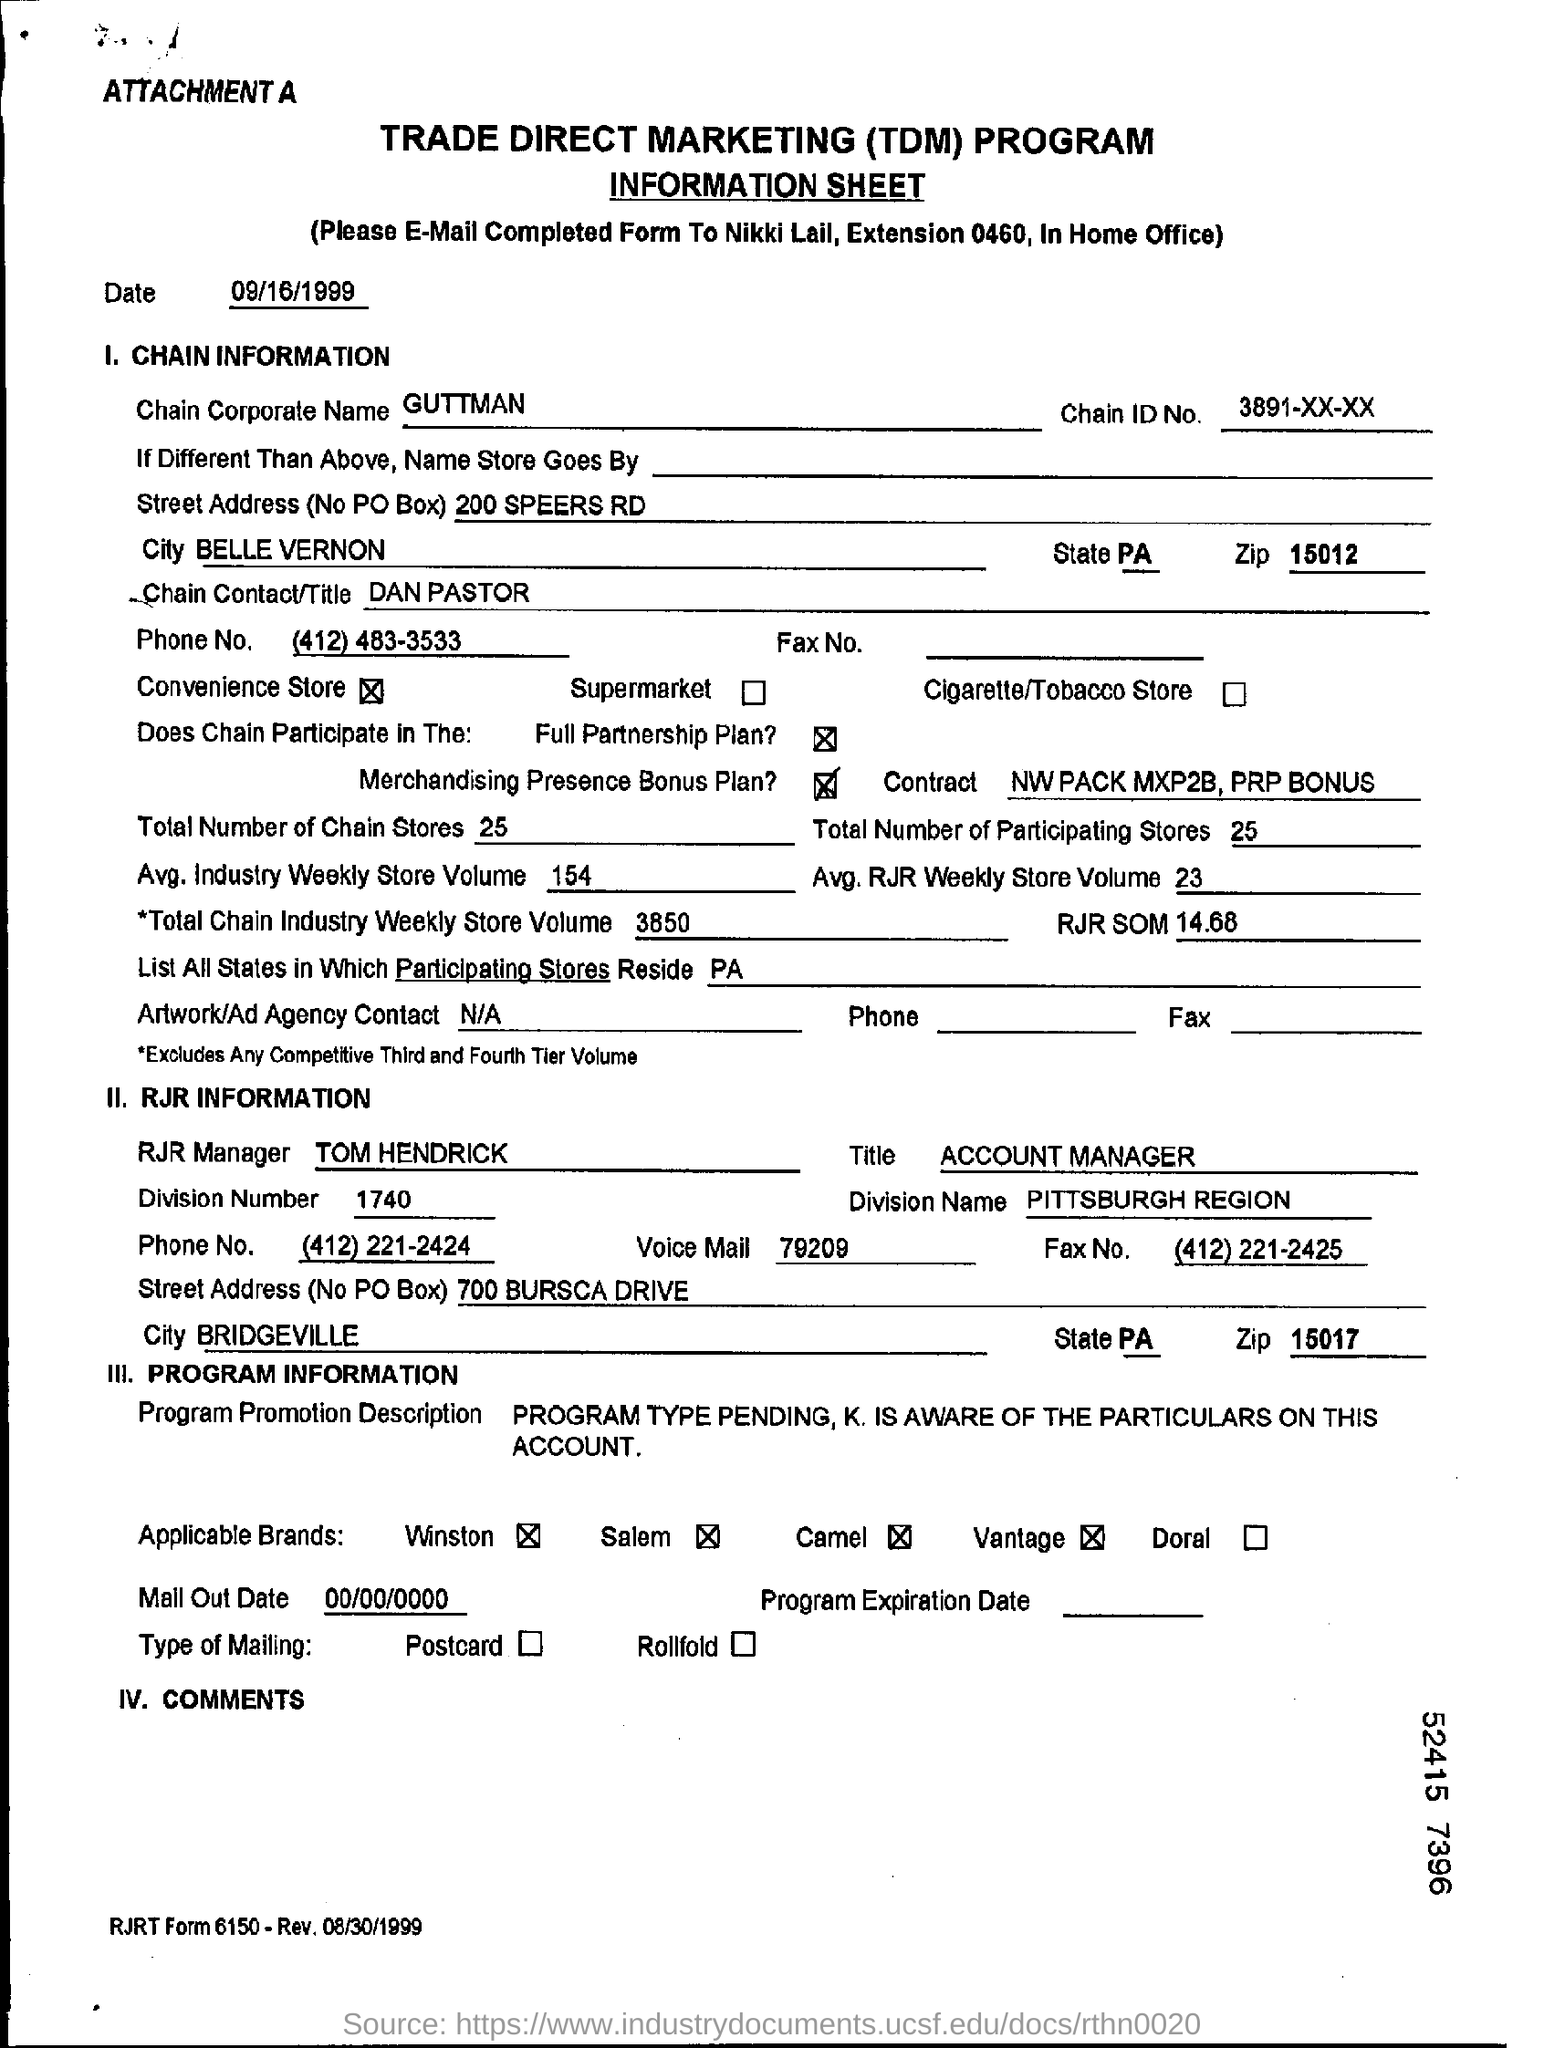What does TDM stand for?
Your answer should be very brief. Trade direct marketing. Who should you e-mail completed form to?
Provide a short and direct response. Nikki Lail. What is the date on the form?
Provide a succinct answer. 09/16/1999. What is the chain corporate name?
Ensure brevity in your answer.  GUTTMAN. What is the chain ID No. given?
Provide a succinct answer. 3891-XX-XX. Who is the Chain Contact/Title?
Provide a short and direct response. Dan pastor. What is the phone number given?
Your answer should be compact. (412) 483-3533. What is the contract specified?
Provide a succinct answer. Nw pack mxp2b , prp bonus. What is the total number of chain stores?
Provide a short and direct response. 25. 